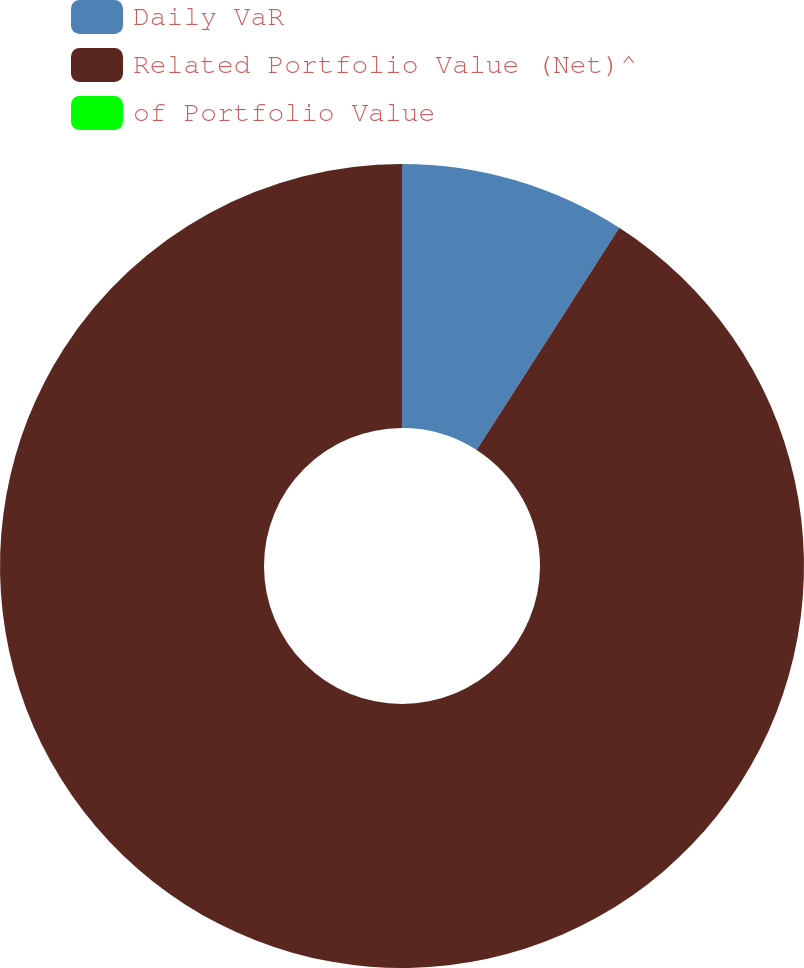Convert chart to OTSL. <chart><loc_0><loc_0><loc_500><loc_500><pie_chart><fcel>Daily VaR<fcel>Related Portfolio Value (Net)^<fcel>of Portfolio Value<nl><fcel>9.09%<fcel>90.91%<fcel>0.0%<nl></chart> 